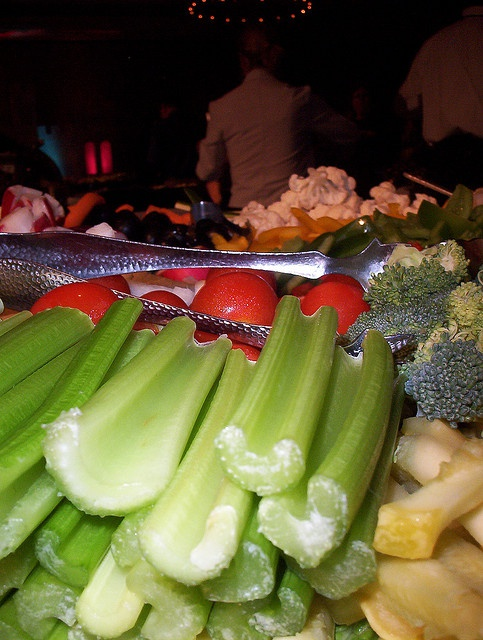Describe the objects in this image and their specific colors. I can see broccoli in black, gray, darkgreen, and tan tones, people in black, maroon, purple, and brown tones, people in black and maroon tones, people in black and maroon tones, and carrot in black, brown, maroon, and red tones in this image. 